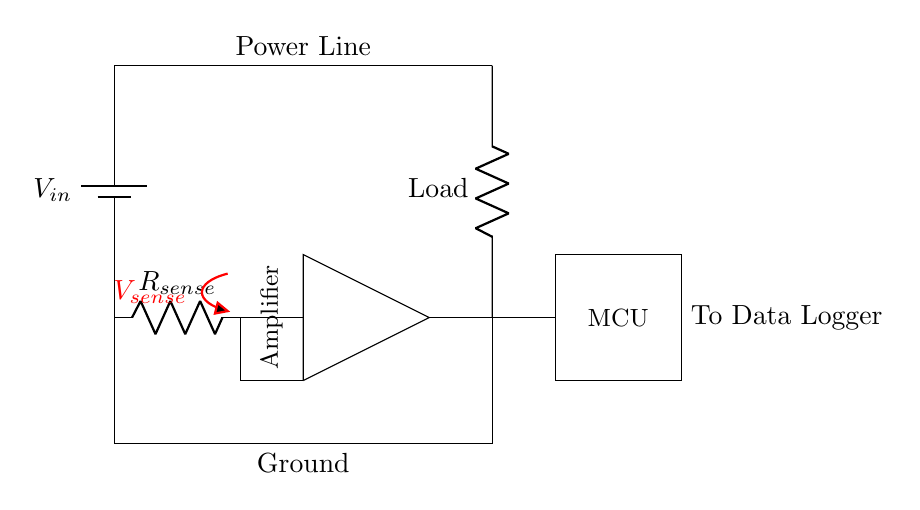What type of component is the sensing resistor? The sensing resistor is indicated by the label "R_sense" in the circuit diagram. It is shown as a resistor symbol connected in series with the power source and load, which is its standard representation in electrical circuits.
Answer: Resistor What is the role of the amplifier in this circuit? The amplifier is positioned directly after the sensing resistor and is responsible for increasing the voltage signal across the sensing resistor for better measurement and processing. It's labeled in the circuit and connects to the microcontroller, indicating its function in the current sensing process.
Answer: Signal enhancement How does the current flow in this circuit? Current flows from the power source (battery) through the load, then through the sensing resistor, where it generates a voltage that is amplified. This configuration follows the series circuit principles. The path can be traced clearly through the components, showing that the current direction is from the power line to ground.
Answer: Series flow What is the purpose of the microcontroller in this setup? The microcontroller (MCU) receives processed voltage (current) data from the amplifier to store and analyze power consumption. Its position in the circuit indicates it is designed to interface with the output of the amplifier and perform calculations or logging.
Answer: Data processing What is the voltage across the sensing resistor? The voltage across the sensing resistor is represented as "V_sense," indicating the measured voltage drop due to the current passing through it. This measurement is crucial for calculating the current based on Ohm's Law (V = IR).
Answer: V_sense What is the impact of increasing the load resistance? Increasing the load resistance would result in a decrease in current flow according to Ohm's Law (I = V/R). Since the circuit operates on a power source, a higher load resistance would decrease the overall current which in turn decreases the voltage across the sensing resistor.
Answer: Decreased current 